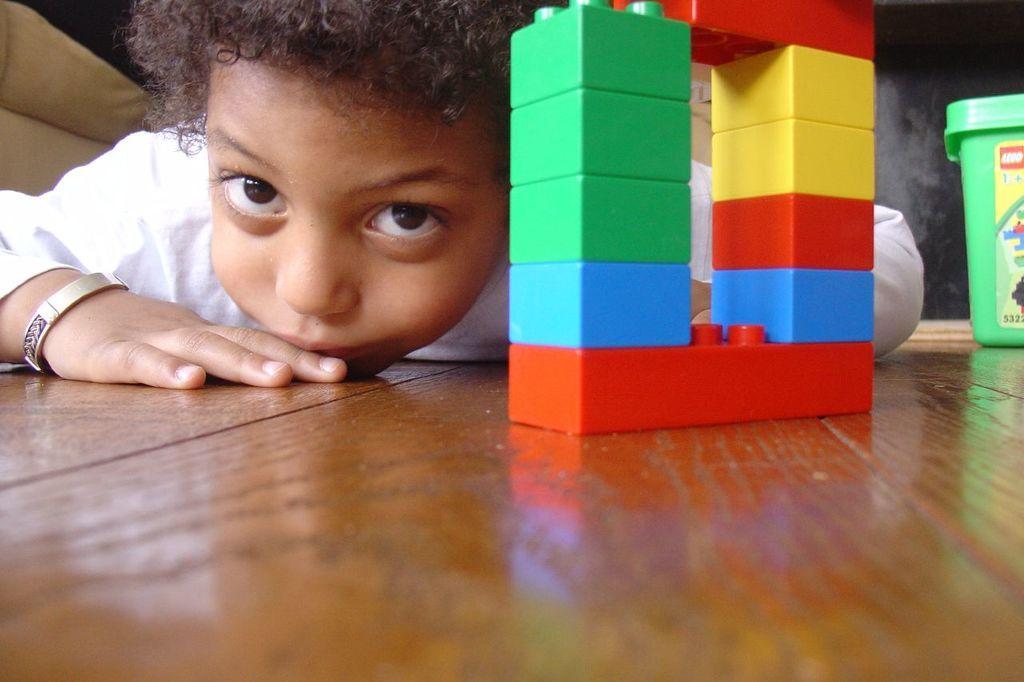How would you summarize this image in a sentence or two? In this image I can see lego bricks on a wooden surface. There is a child and a green box at the back. 